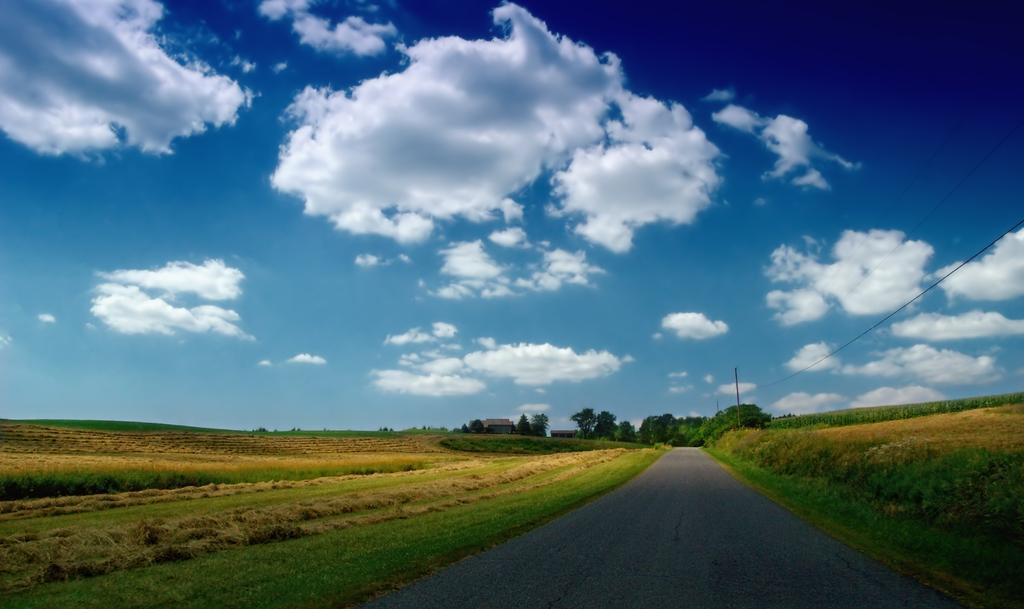Can you describe this image briefly? This image is clicked on the road. At the bottom, there is road. To the left and right, there is green grass. In the background, there are trees. To the top, there are clouds in the sky. 